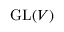<formula> <loc_0><loc_0><loc_500><loc_500>{ G L } ( V )</formula> 